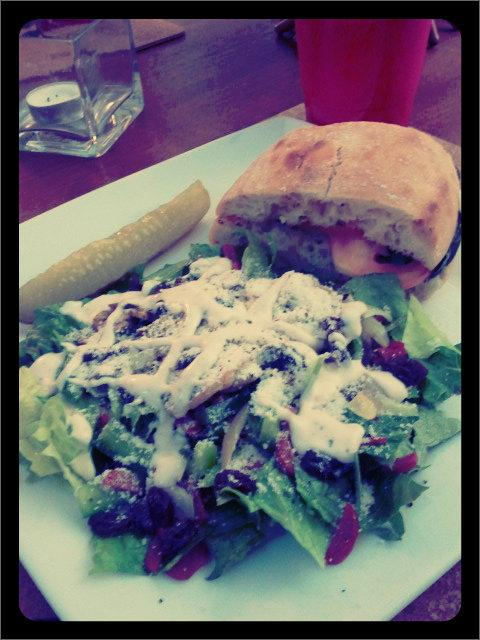What shape is the pickle cut in?

Choices:
A) spear
B) chunks
C) sliced
D) cubed spear 